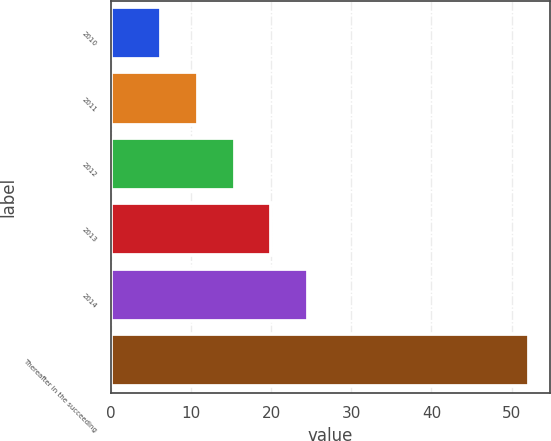<chart> <loc_0><loc_0><loc_500><loc_500><bar_chart><fcel>2010<fcel>2011<fcel>2012<fcel>2013<fcel>2014<fcel>Thereafter in the succeeding<nl><fcel>6.2<fcel>10.8<fcel>15.4<fcel>20<fcel>24.6<fcel>52.2<nl></chart> 